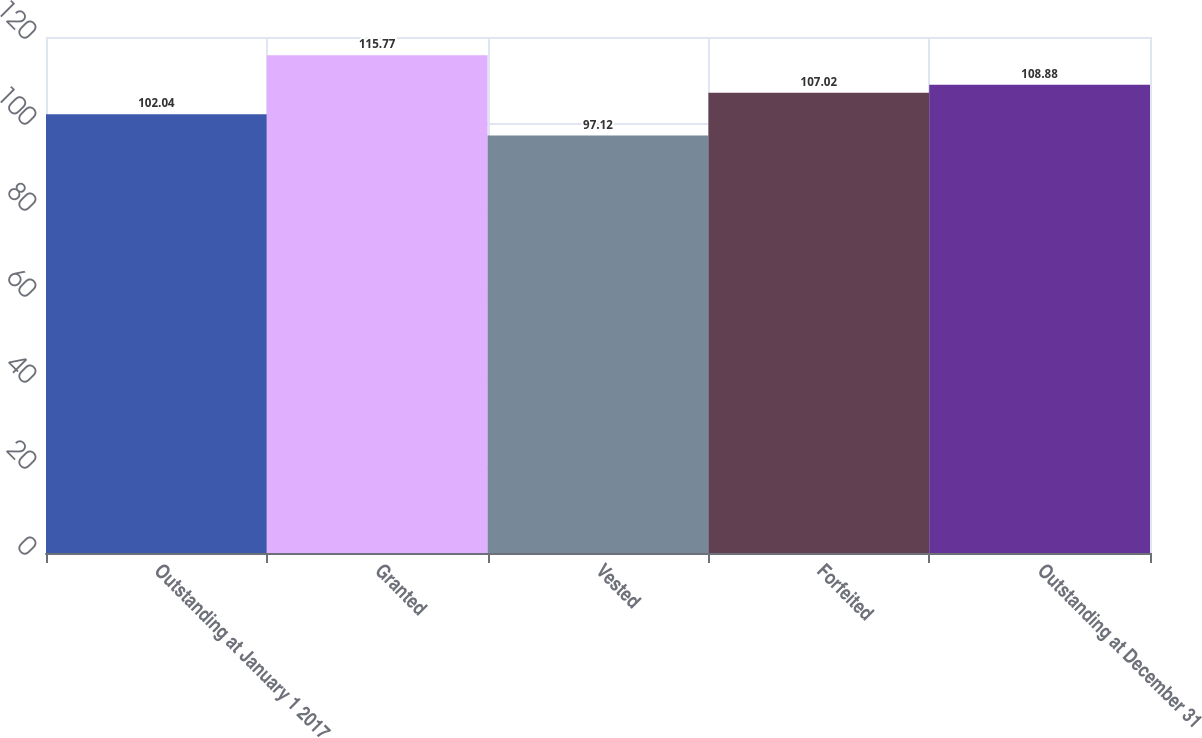<chart> <loc_0><loc_0><loc_500><loc_500><bar_chart><fcel>Outstanding at January 1 2017<fcel>Granted<fcel>Vested<fcel>Forfeited<fcel>Outstanding at December 31<nl><fcel>102.04<fcel>115.77<fcel>97.12<fcel>107.02<fcel>108.88<nl></chart> 